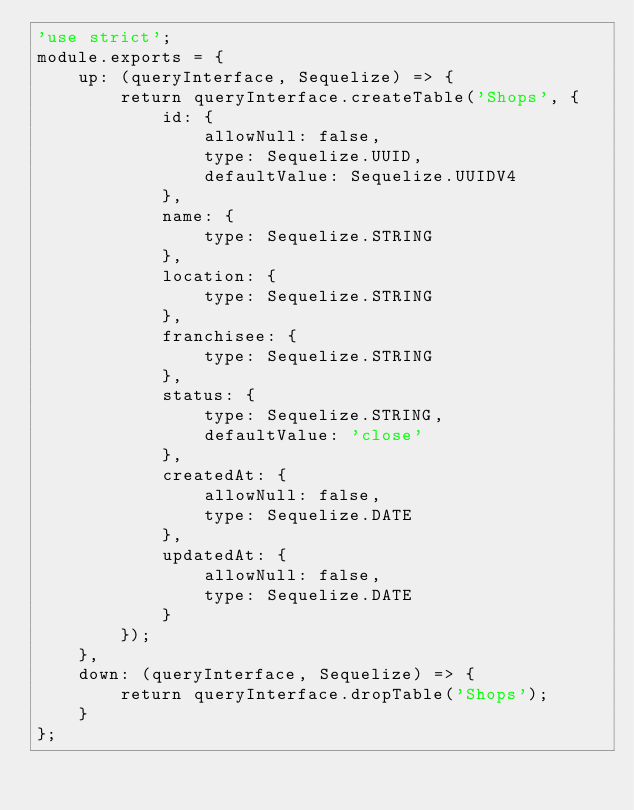<code> <loc_0><loc_0><loc_500><loc_500><_JavaScript_>'use strict';
module.exports = {
	up: (queryInterface, Sequelize) => {
		return queryInterface.createTable('Shops', {
			id: {
				allowNull: false,
				type: Sequelize.UUID,
				defaultValue: Sequelize.UUIDV4
			},
			name: {
				type: Sequelize.STRING
			},
			location: {
				type: Sequelize.STRING
			},
			franchisee: {
				type: Sequelize.STRING
			},
			status: {
				type: Sequelize.STRING,
				defaultValue: 'close'
			},
			createdAt: {
				allowNull: false,
				type: Sequelize.DATE
			},
			updatedAt: {
				allowNull: false,
				type: Sequelize.DATE
			}
		});
	},
	down: (queryInterface, Sequelize) => {
		return queryInterface.dropTable('Shops');
	}
};</code> 